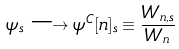Convert formula to latex. <formula><loc_0><loc_0><loc_500><loc_500>\psi _ { s } \longrightarrow \psi ^ { C } [ n ] _ { s } \equiv \frac { W _ { n , s } } { W _ { n } }</formula> 